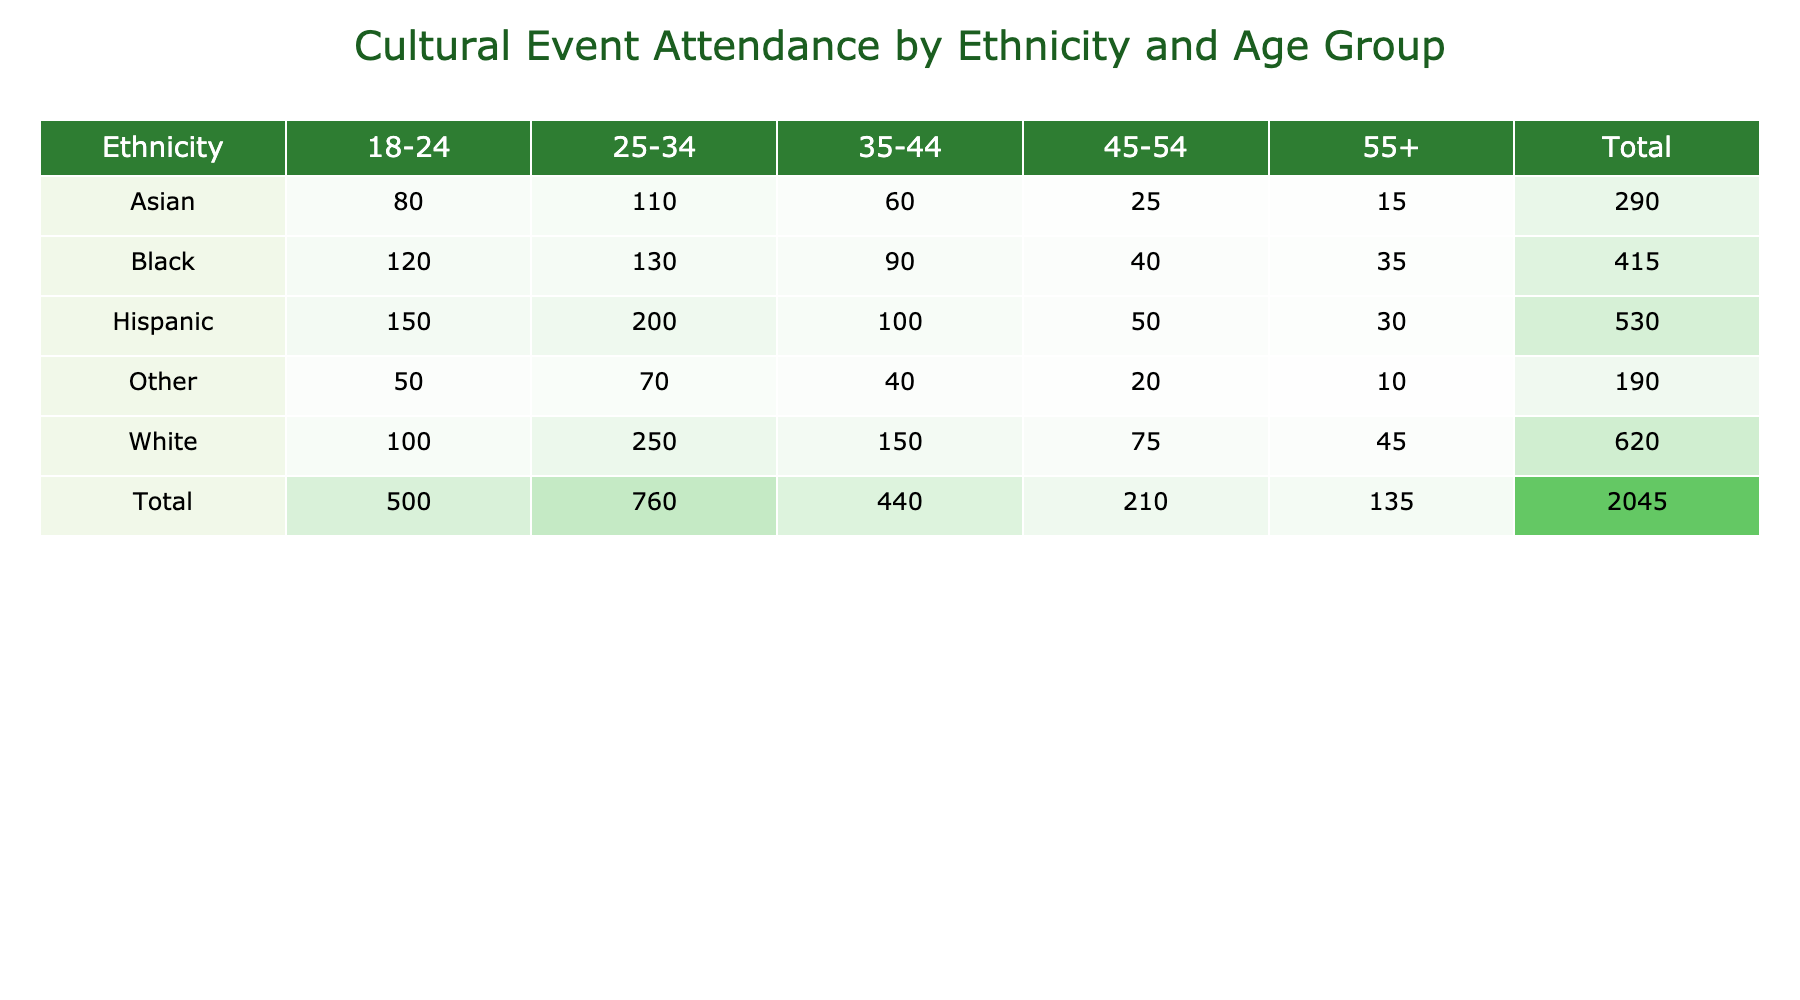What is the total attendance for the Hispanic age group of 35-44? The table shows the attendance for Hispanic individuals in the age group of 35-44 as 100. Thus, the total attendance for this specific age group is directly retrieved from the table.
Answer: 100 Which ethnic group has the highest attendance in the 25-34 age group? Looking at the 25-34 age group, we can see that the White ethnicity has the highest attendance, with a value of 250. This is compared against the attendance values of other ethnic groups in the same age group.
Answer: White What is the average attendance of the Asian age group? The attendance values for Asians across all age groups are 80, 110, 60, 25, and 15. To calculate the average: (80 + 110 + 60 + 25 + 15) = 290, then divide by 5 (number of entries): 290/5 = 58.
Answer: 58 Is the total attendance for Black individuals greater than that of Other ethnicities? To compare total attendance, we sum the entries for each group: Black has (120 + 130 + 90 + 40 + 35) = 415, while Other has (50 + 70 + 40 + 20 + 10) = 190. Since 415 is greater than 190, the answer is yes.
Answer: Yes What is the difference in total attendance between the age groups 18-24 and 55+ for the Hispanic ethnicity? For Hispanic individuals, the attendance for the 18-24 age group is 150 and for the 55+ age group is 30. The difference is calculated as 150 - 30 = 120.
Answer: 120 Which ethnicity has the lowest total attendance in the 45-54 age group? In the 45-54 age group, the attendance values are Hispanic (50), White (75), Black (40), Asian (25), and Other (20). The lowest attendance is found by comparing these values: Other has the lowest with 20.
Answer: Other How many more people attended the cultural event in the 25-34 age group compared to the 45-54 age group for the White ethnicity? For the White ethnicity, attendance in the 25-34 age group is 250, and in the 45-54 age group, it is 75. The difference calculates as 250 - 75 = 175.
Answer: 175 Did more than 200 people attend the cultural event in the 25-34 age group overall? By summing the values for all ethnic groups in the 25-34 age group: Hispanic (200) + White (250) + Black (130) + Asian (110) + Other (70) = 760. Since 760 is greater than 200, the answer is yes.
Answer: Yes 